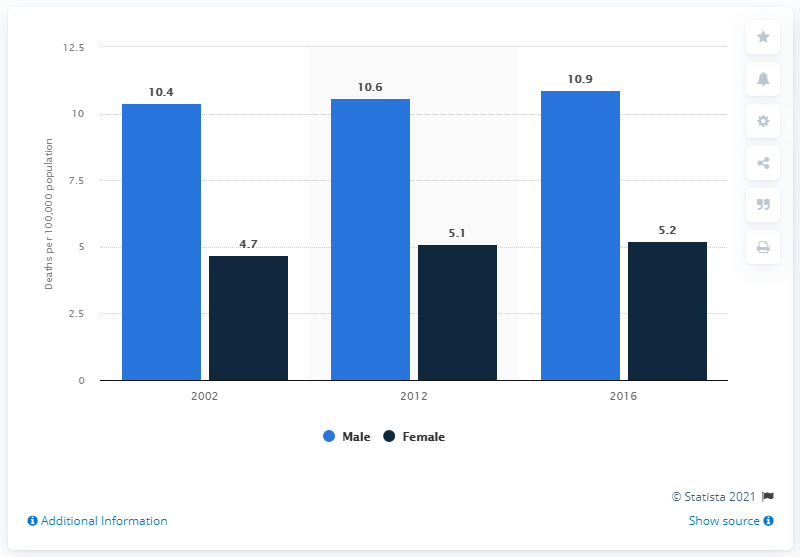List a handful of essential elements in this visual. In 2016, the male death rate per 100,000 population in Canada was 10.9. 